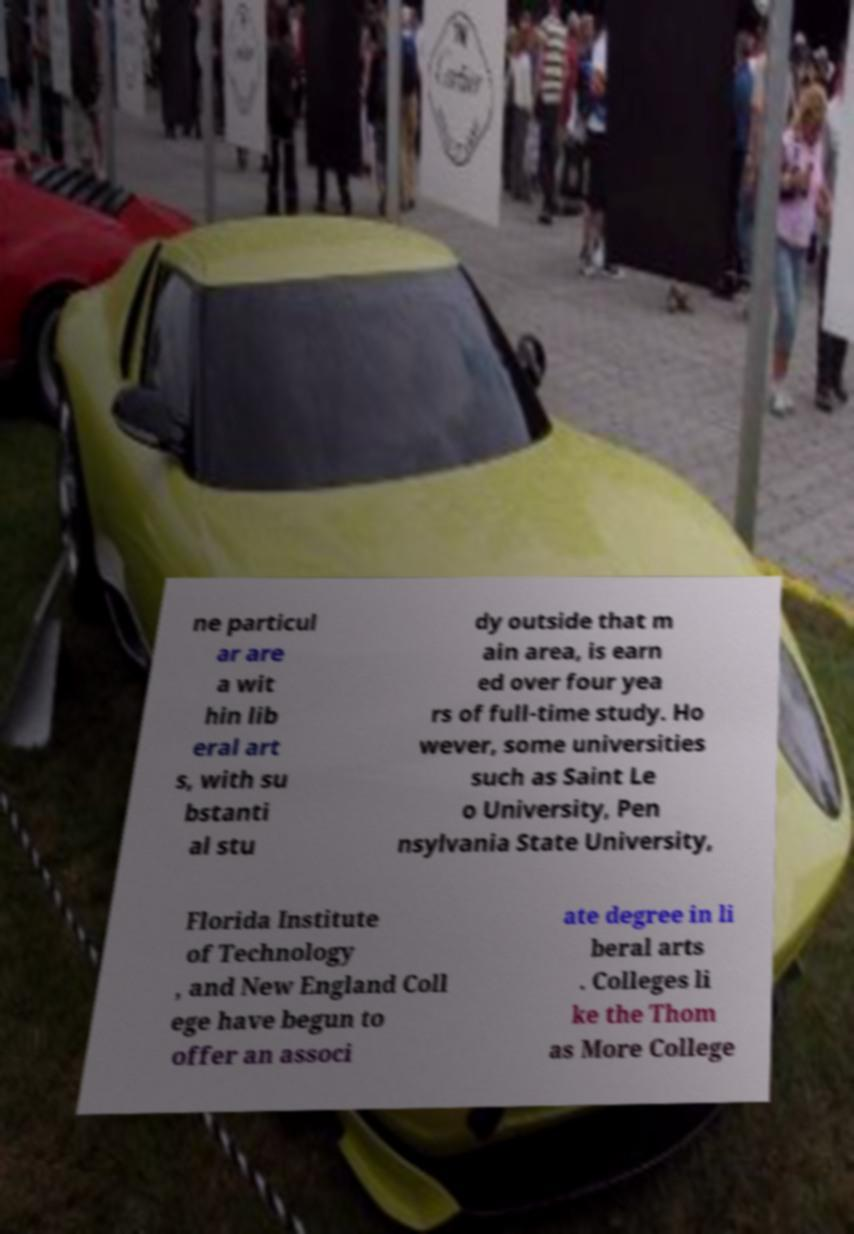I need the written content from this picture converted into text. Can you do that? ne particul ar are a wit hin lib eral art s, with su bstanti al stu dy outside that m ain area, is earn ed over four yea rs of full-time study. Ho wever, some universities such as Saint Le o University, Pen nsylvania State University, Florida Institute of Technology , and New England Coll ege have begun to offer an associ ate degree in li beral arts . Colleges li ke the Thom as More College 